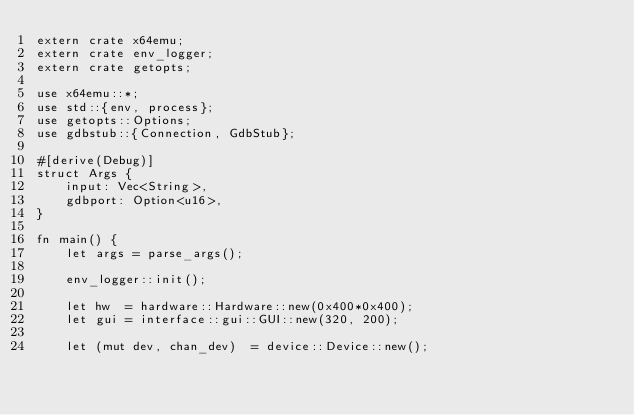Convert code to text. <code><loc_0><loc_0><loc_500><loc_500><_Rust_>extern crate x64emu;
extern crate env_logger;
extern crate getopts;

use x64emu::*;
use std::{env, process};
use getopts::Options;
use gdbstub::{Connection, GdbStub};

#[derive(Debug)]
struct Args {
    input: Vec<String>,
    gdbport: Option<u16>,
}

fn main() {
    let args = parse_args();

    env_logger::init();

    let hw  = hardware::Hardware::new(0x400*0x400);
    let gui = interface::gui::GUI::new(320, 200);

    let (mut dev, chan_dev)  = device::Device::new();</code> 